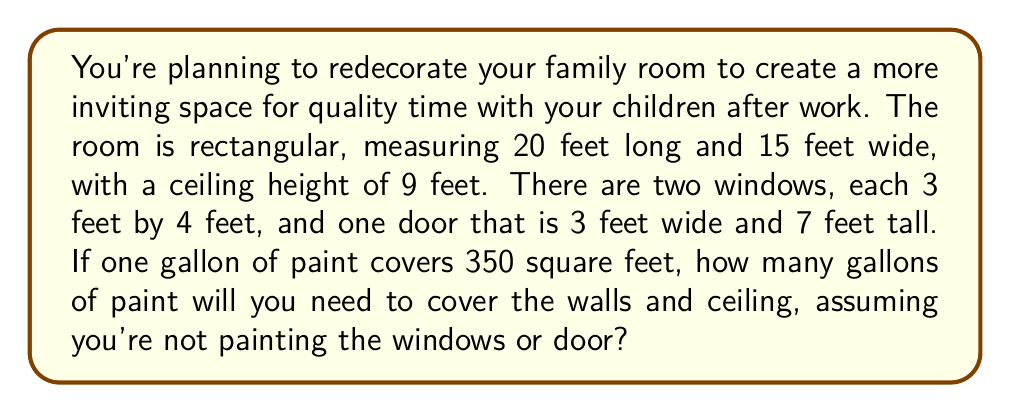Can you answer this question? Let's break this down step-by-step:

1. Calculate the total wall area:
   - Perimeter of the room: $2(20 + 15) = 70$ feet
   - Wall area: $70 \times 9 = 630$ square feet

2. Calculate the ceiling area:
   - Ceiling area: $20 \times 15 = 300$ square feet

3. Calculate the total area to be painted:
   - Total area: $630 + 300 = 930$ square feet

4. Calculate the area of windows and door:
   - Windows: $2(3 \times 4) = 24$ square feet
   - Door: $3 \times 7 = 21$ square feet
   - Total area to subtract: $24 + 21 = 45$ square feet

5. Calculate the net area to be painted:
   - Net area: $930 - 45 = 885$ square feet

6. Calculate the number of gallons needed:
   - Gallons needed: $\frac{885}{350} = 2.53$ gallons

7. Round up to the nearest whole gallon:
   - Final amount: 3 gallons
Answer: 3 gallons 